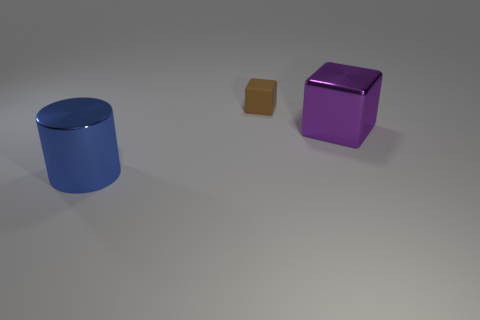Add 2 big green rubber things. How many objects exist? 5 Subtract all blocks. How many objects are left? 1 Subtract 0 brown spheres. How many objects are left? 3 Subtract all gray cylinders. Subtract all large purple shiny things. How many objects are left? 2 Add 3 big things. How many big things are left? 5 Add 3 large blue cylinders. How many large blue cylinders exist? 4 